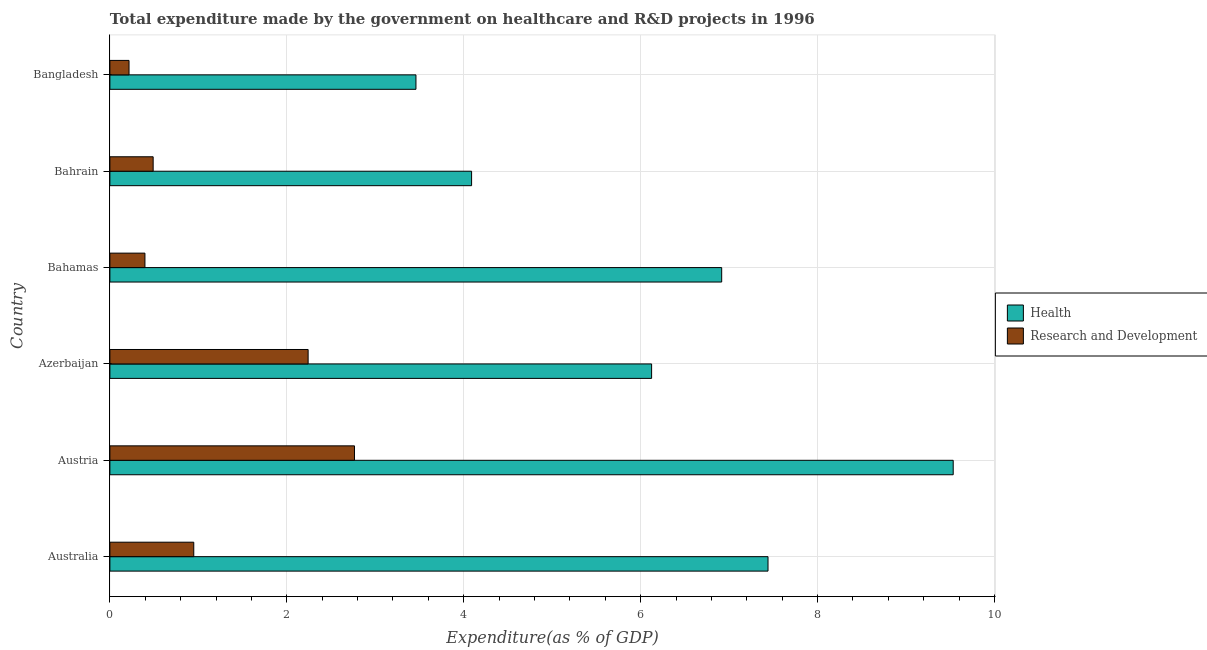How many different coloured bars are there?
Your response must be concise. 2. How many groups of bars are there?
Offer a very short reply. 6. How many bars are there on the 6th tick from the top?
Your answer should be very brief. 2. How many bars are there on the 3rd tick from the bottom?
Give a very brief answer. 2. What is the label of the 4th group of bars from the top?
Provide a short and direct response. Azerbaijan. In how many cases, is the number of bars for a given country not equal to the number of legend labels?
Your answer should be compact. 0. What is the expenditure in healthcare in Bangladesh?
Ensure brevity in your answer.  3.46. Across all countries, what is the maximum expenditure in r&d?
Give a very brief answer. 2.77. Across all countries, what is the minimum expenditure in r&d?
Offer a very short reply. 0.22. In which country was the expenditure in healthcare maximum?
Provide a short and direct response. Austria. In which country was the expenditure in r&d minimum?
Provide a succinct answer. Bangladesh. What is the total expenditure in r&d in the graph?
Provide a succinct answer. 7.06. What is the difference between the expenditure in healthcare in Austria and that in Azerbaijan?
Offer a very short reply. 3.41. What is the difference between the expenditure in healthcare in Bahrain and the expenditure in r&d in Bahamas?
Provide a short and direct response. 3.69. What is the average expenditure in healthcare per country?
Ensure brevity in your answer.  6.26. What is the difference between the expenditure in r&d and expenditure in healthcare in Bahrain?
Offer a very short reply. -3.6. What is the ratio of the expenditure in healthcare in Azerbaijan to that in Bangladesh?
Offer a terse response. 1.77. Is the difference between the expenditure in healthcare in Australia and Bahrain greater than the difference between the expenditure in r&d in Australia and Bahrain?
Ensure brevity in your answer.  Yes. What is the difference between the highest and the second highest expenditure in healthcare?
Provide a short and direct response. 2.09. What is the difference between the highest and the lowest expenditure in healthcare?
Provide a succinct answer. 6.07. Is the sum of the expenditure in r&d in Austria and Bahrain greater than the maximum expenditure in healthcare across all countries?
Ensure brevity in your answer.  No. What does the 2nd bar from the top in Bahamas represents?
Give a very brief answer. Health. What does the 1st bar from the bottom in Bangladesh represents?
Your answer should be very brief. Health. Are all the bars in the graph horizontal?
Ensure brevity in your answer.  Yes. What is the difference between two consecutive major ticks on the X-axis?
Offer a terse response. 2. What is the title of the graph?
Ensure brevity in your answer.  Total expenditure made by the government on healthcare and R&D projects in 1996. Does "% of gross capital formation" appear as one of the legend labels in the graph?
Provide a succinct answer. No. What is the label or title of the X-axis?
Offer a very short reply. Expenditure(as % of GDP). What is the Expenditure(as % of GDP) in Health in Australia?
Offer a very short reply. 7.44. What is the Expenditure(as % of GDP) in Research and Development in Australia?
Give a very brief answer. 0.95. What is the Expenditure(as % of GDP) in Health in Austria?
Provide a short and direct response. 9.53. What is the Expenditure(as % of GDP) in Research and Development in Austria?
Offer a very short reply. 2.77. What is the Expenditure(as % of GDP) of Health in Azerbaijan?
Provide a succinct answer. 6.12. What is the Expenditure(as % of GDP) in Research and Development in Azerbaijan?
Offer a very short reply. 2.24. What is the Expenditure(as % of GDP) of Health in Bahamas?
Ensure brevity in your answer.  6.92. What is the Expenditure(as % of GDP) of Research and Development in Bahamas?
Keep it short and to the point. 0.4. What is the Expenditure(as % of GDP) in Health in Bahrain?
Give a very brief answer. 4.09. What is the Expenditure(as % of GDP) of Research and Development in Bahrain?
Offer a very short reply. 0.49. What is the Expenditure(as % of GDP) of Health in Bangladesh?
Ensure brevity in your answer.  3.46. What is the Expenditure(as % of GDP) of Research and Development in Bangladesh?
Your answer should be very brief. 0.22. Across all countries, what is the maximum Expenditure(as % of GDP) in Health?
Your answer should be very brief. 9.53. Across all countries, what is the maximum Expenditure(as % of GDP) of Research and Development?
Provide a succinct answer. 2.77. Across all countries, what is the minimum Expenditure(as % of GDP) of Health?
Make the answer very short. 3.46. Across all countries, what is the minimum Expenditure(as % of GDP) in Research and Development?
Provide a short and direct response. 0.22. What is the total Expenditure(as % of GDP) in Health in the graph?
Your answer should be very brief. 37.56. What is the total Expenditure(as % of GDP) in Research and Development in the graph?
Offer a terse response. 7.06. What is the difference between the Expenditure(as % of GDP) in Health in Australia and that in Austria?
Keep it short and to the point. -2.09. What is the difference between the Expenditure(as % of GDP) in Research and Development in Australia and that in Austria?
Your answer should be very brief. -1.82. What is the difference between the Expenditure(as % of GDP) in Health in Australia and that in Azerbaijan?
Give a very brief answer. 1.32. What is the difference between the Expenditure(as % of GDP) in Research and Development in Australia and that in Azerbaijan?
Offer a very short reply. -1.29. What is the difference between the Expenditure(as % of GDP) of Health in Australia and that in Bahamas?
Provide a short and direct response. 0.52. What is the difference between the Expenditure(as % of GDP) in Research and Development in Australia and that in Bahamas?
Your response must be concise. 0.55. What is the difference between the Expenditure(as % of GDP) in Health in Australia and that in Bahrain?
Offer a very short reply. 3.35. What is the difference between the Expenditure(as % of GDP) in Research and Development in Australia and that in Bahrain?
Ensure brevity in your answer.  0.46. What is the difference between the Expenditure(as % of GDP) of Health in Australia and that in Bangladesh?
Keep it short and to the point. 3.98. What is the difference between the Expenditure(as % of GDP) of Research and Development in Australia and that in Bangladesh?
Provide a succinct answer. 0.73. What is the difference between the Expenditure(as % of GDP) of Health in Austria and that in Azerbaijan?
Provide a short and direct response. 3.41. What is the difference between the Expenditure(as % of GDP) of Research and Development in Austria and that in Azerbaijan?
Provide a succinct answer. 0.52. What is the difference between the Expenditure(as % of GDP) in Health in Austria and that in Bahamas?
Provide a short and direct response. 2.62. What is the difference between the Expenditure(as % of GDP) in Research and Development in Austria and that in Bahamas?
Offer a terse response. 2.37. What is the difference between the Expenditure(as % of GDP) in Health in Austria and that in Bahrain?
Your response must be concise. 5.44. What is the difference between the Expenditure(as % of GDP) in Research and Development in Austria and that in Bahrain?
Offer a terse response. 2.28. What is the difference between the Expenditure(as % of GDP) in Health in Austria and that in Bangladesh?
Give a very brief answer. 6.07. What is the difference between the Expenditure(as % of GDP) in Research and Development in Austria and that in Bangladesh?
Offer a very short reply. 2.55. What is the difference between the Expenditure(as % of GDP) in Health in Azerbaijan and that in Bahamas?
Offer a very short reply. -0.79. What is the difference between the Expenditure(as % of GDP) of Research and Development in Azerbaijan and that in Bahamas?
Your answer should be compact. 1.84. What is the difference between the Expenditure(as % of GDP) of Health in Azerbaijan and that in Bahrain?
Provide a succinct answer. 2.04. What is the difference between the Expenditure(as % of GDP) of Research and Development in Azerbaijan and that in Bahrain?
Offer a very short reply. 1.75. What is the difference between the Expenditure(as % of GDP) in Health in Azerbaijan and that in Bangladesh?
Ensure brevity in your answer.  2.66. What is the difference between the Expenditure(as % of GDP) of Research and Development in Azerbaijan and that in Bangladesh?
Provide a short and direct response. 2.02. What is the difference between the Expenditure(as % of GDP) in Health in Bahamas and that in Bahrain?
Your response must be concise. 2.83. What is the difference between the Expenditure(as % of GDP) of Research and Development in Bahamas and that in Bahrain?
Your answer should be compact. -0.09. What is the difference between the Expenditure(as % of GDP) in Health in Bahamas and that in Bangladesh?
Offer a terse response. 3.46. What is the difference between the Expenditure(as % of GDP) of Research and Development in Bahamas and that in Bangladesh?
Ensure brevity in your answer.  0.18. What is the difference between the Expenditure(as % of GDP) of Health in Bahrain and that in Bangladesh?
Ensure brevity in your answer.  0.63. What is the difference between the Expenditure(as % of GDP) of Research and Development in Bahrain and that in Bangladesh?
Your response must be concise. 0.27. What is the difference between the Expenditure(as % of GDP) of Health in Australia and the Expenditure(as % of GDP) of Research and Development in Austria?
Make the answer very short. 4.67. What is the difference between the Expenditure(as % of GDP) of Health in Australia and the Expenditure(as % of GDP) of Research and Development in Azerbaijan?
Your response must be concise. 5.2. What is the difference between the Expenditure(as % of GDP) in Health in Australia and the Expenditure(as % of GDP) in Research and Development in Bahamas?
Your answer should be compact. 7.04. What is the difference between the Expenditure(as % of GDP) in Health in Australia and the Expenditure(as % of GDP) in Research and Development in Bahrain?
Your answer should be very brief. 6.95. What is the difference between the Expenditure(as % of GDP) in Health in Australia and the Expenditure(as % of GDP) in Research and Development in Bangladesh?
Give a very brief answer. 7.22. What is the difference between the Expenditure(as % of GDP) in Health in Austria and the Expenditure(as % of GDP) in Research and Development in Azerbaijan?
Keep it short and to the point. 7.29. What is the difference between the Expenditure(as % of GDP) in Health in Austria and the Expenditure(as % of GDP) in Research and Development in Bahamas?
Provide a short and direct response. 9.14. What is the difference between the Expenditure(as % of GDP) of Health in Austria and the Expenditure(as % of GDP) of Research and Development in Bahrain?
Your response must be concise. 9.04. What is the difference between the Expenditure(as % of GDP) of Health in Austria and the Expenditure(as % of GDP) of Research and Development in Bangladesh?
Provide a short and direct response. 9.32. What is the difference between the Expenditure(as % of GDP) in Health in Azerbaijan and the Expenditure(as % of GDP) in Research and Development in Bahamas?
Provide a short and direct response. 5.73. What is the difference between the Expenditure(as % of GDP) of Health in Azerbaijan and the Expenditure(as % of GDP) of Research and Development in Bahrain?
Give a very brief answer. 5.63. What is the difference between the Expenditure(as % of GDP) of Health in Azerbaijan and the Expenditure(as % of GDP) of Research and Development in Bangladesh?
Offer a very short reply. 5.91. What is the difference between the Expenditure(as % of GDP) in Health in Bahamas and the Expenditure(as % of GDP) in Research and Development in Bahrain?
Your response must be concise. 6.43. What is the difference between the Expenditure(as % of GDP) of Health in Bahamas and the Expenditure(as % of GDP) of Research and Development in Bangladesh?
Your answer should be compact. 6.7. What is the difference between the Expenditure(as % of GDP) in Health in Bahrain and the Expenditure(as % of GDP) in Research and Development in Bangladesh?
Your answer should be very brief. 3.87. What is the average Expenditure(as % of GDP) of Health per country?
Keep it short and to the point. 6.26. What is the average Expenditure(as % of GDP) of Research and Development per country?
Keep it short and to the point. 1.18. What is the difference between the Expenditure(as % of GDP) in Health and Expenditure(as % of GDP) in Research and Development in Australia?
Provide a succinct answer. 6.49. What is the difference between the Expenditure(as % of GDP) in Health and Expenditure(as % of GDP) in Research and Development in Austria?
Offer a very short reply. 6.77. What is the difference between the Expenditure(as % of GDP) in Health and Expenditure(as % of GDP) in Research and Development in Azerbaijan?
Your answer should be compact. 3.88. What is the difference between the Expenditure(as % of GDP) of Health and Expenditure(as % of GDP) of Research and Development in Bahamas?
Your answer should be compact. 6.52. What is the difference between the Expenditure(as % of GDP) in Health and Expenditure(as % of GDP) in Research and Development in Bahrain?
Keep it short and to the point. 3.6. What is the difference between the Expenditure(as % of GDP) in Health and Expenditure(as % of GDP) in Research and Development in Bangladesh?
Your answer should be compact. 3.24. What is the ratio of the Expenditure(as % of GDP) of Health in Australia to that in Austria?
Offer a terse response. 0.78. What is the ratio of the Expenditure(as % of GDP) in Research and Development in Australia to that in Austria?
Your response must be concise. 0.34. What is the ratio of the Expenditure(as % of GDP) of Health in Australia to that in Azerbaijan?
Offer a very short reply. 1.21. What is the ratio of the Expenditure(as % of GDP) of Research and Development in Australia to that in Azerbaijan?
Your answer should be compact. 0.42. What is the ratio of the Expenditure(as % of GDP) in Health in Australia to that in Bahamas?
Offer a terse response. 1.08. What is the ratio of the Expenditure(as % of GDP) of Research and Development in Australia to that in Bahamas?
Ensure brevity in your answer.  2.39. What is the ratio of the Expenditure(as % of GDP) in Health in Australia to that in Bahrain?
Keep it short and to the point. 1.82. What is the ratio of the Expenditure(as % of GDP) of Research and Development in Australia to that in Bahrain?
Give a very brief answer. 1.94. What is the ratio of the Expenditure(as % of GDP) of Health in Australia to that in Bangladesh?
Offer a terse response. 2.15. What is the ratio of the Expenditure(as % of GDP) of Research and Development in Australia to that in Bangladesh?
Give a very brief answer. 4.38. What is the ratio of the Expenditure(as % of GDP) in Health in Austria to that in Azerbaijan?
Your answer should be compact. 1.56. What is the ratio of the Expenditure(as % of GDP) of Research and Development in Austria to that in Azerbaijan?
Provide a short and direct response. 1.23. What is the ratio of the Expenditure(as % of GDP) in Health in Austria to that in Bahamas?
Give a very brief answer. 1.38. What is the ratio of the Expenditure(as % of GDP) in Research and Development in Austria to that in Bahamas?
Make the answer very short. 6.98. What is the ratio of the Expenditure(as % of GDP) in Health in Austria to that in Bahrain?
Your answer should be very brief. 2.33. What is the ratio of the Expenditure(as % of GDP) in Research and Development in Austria to that in Bahrain?
Offer a very short reply. 5.65. What is the ratio of the Expenditure(as % of GDP) of Health in Austria to that in Bangladesh?
Your answer should be very brief. 2.76. What is the ratio of the Expenditure(as % of GDP) in Research and Development in Austria to that in Bangladesh?
Your response must be concise. 12.77. What is the ratio of the Expenditure(as % of GDP) in Health in Azerbaijan to that in Bahamas?
Your response must be concise. 0.89. What is the ratio of the Expenditure(as % of GDP) of Research and Development in Azerbaijan to that in Bahamas?
Provide a short and direct response. 5.66. What is the ratio of the Expenditure(as % of GDP) of Health in Azerbaijan to that in Bahrain?
Provide a succinct answer. 1.5. What is the ratio of the Expenditure(as % of GDP) in Research and Development in Azerbaijan to that in Bahrain?
Your response must be concise. 4.58. What is the ratio of the Expenditure(as % of GDP) of Health in Azerbaijan to that in Bangladesh?
Give a very brief answer. 1.77. What is the ratio of the Expenditure(as % of GDP) in Research and Development in Azerbaijan to that in Bangladesh?
Ensure brevity in your answer.  10.35. What is the ratio of the Expenditure(as % of GDP) in Health in Bahamas to that in Bahrain?
Make the answer very short. 1.69. What is the ratio of the Expenditure(as % of GDP) of Research and Development in Bahamas to that in Bahrain?
Offer a terse response. 0.81. What is the ratio of the Expenditure(as % of GDP) of Health in Bahamas to that in Bangladesh?
Your answer should be very brief. 2. What is the ratio of the Expenditure(as % of GDP) in Research and Development in Bahamas to that in Bangladesh?
Your answer should be compact. 1.83. What is the ratio of the Expenditure(as % of GDP) of Health in Bahrain to that in Bangladesh?
Your response must be concise. 1.18. What is the ratio of the Expenditure(as % of GDP) in Research and Development in Bahrain to that in Bangladesh?
Provide a succinct answer. 2.26. What is the difference between the highest and the second highest Expenditure(as % of GDP) of Health?
Your answer should be compact. 2.09. What is the difference between the highest and the second highest Expenditure(as % of GDP) of Research and Development?
Give a very brief answer. 0.52. What is the difference between the highest and the lowest Expenditure(as % of GDP) in Health?
Your response must be concise. 6.07. What is the difference between the highest and the lowest Expenditure(as % of GDP) of Research and Development?
Provide a short and direct response. 2.55. 